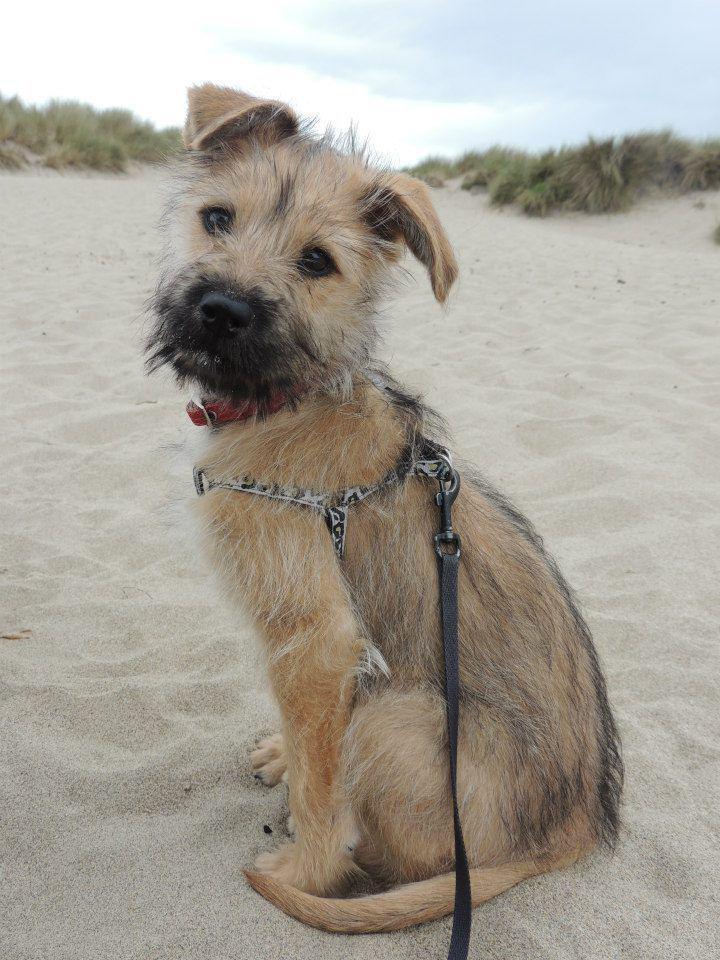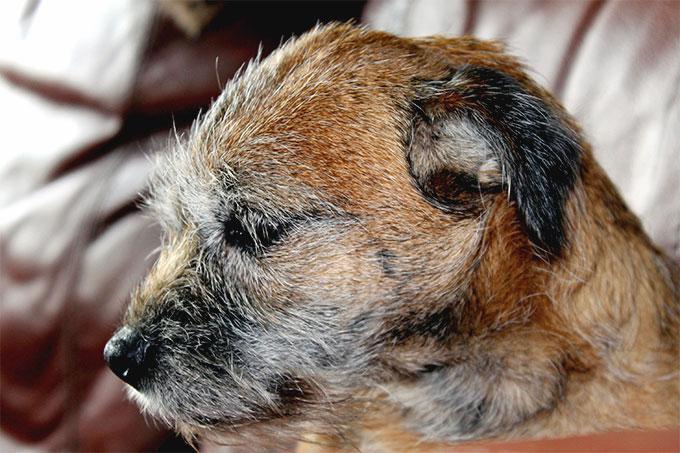The first image is the image on the left, the second image is the image on the right. Assess this claim about the two images: "A dog is shown in profile standing on green grass in at least one image.". Correct or not? Answer yes or no. No. The first image is the image on the left, the second image is the image on the right. Considering the images on both sides, is "One dog is wearing a harness." valid? Answer yes or no. Yes. 